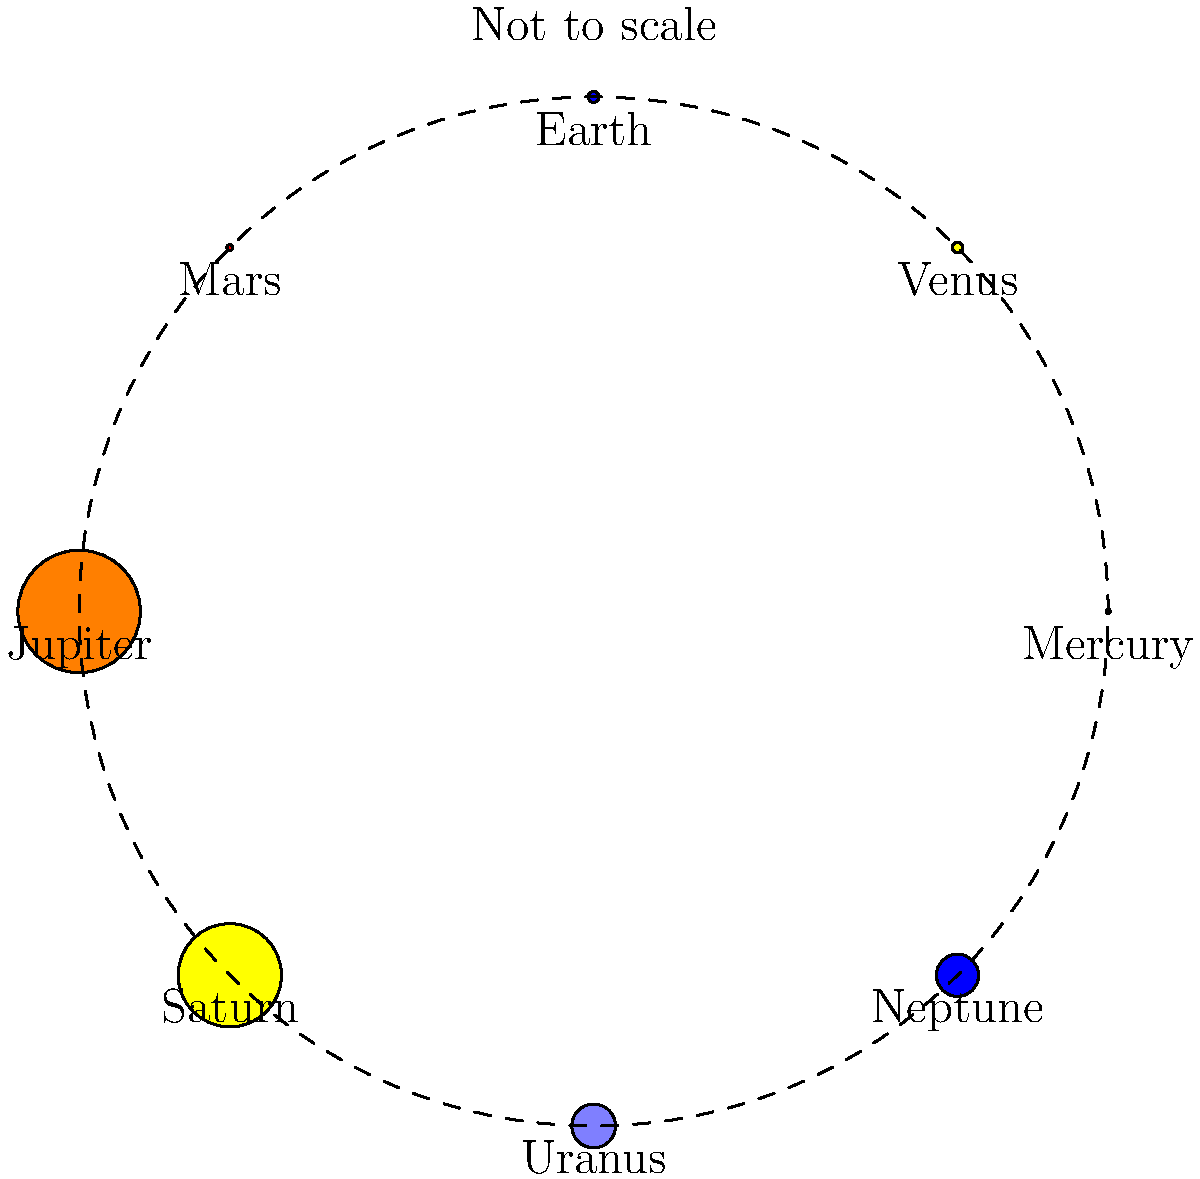In designing a Rocket Raccoon costume for a space-themed event, you want to incorporate accurate astronomical details. Which planet in our solar system would require the most fabric to create a proportionally sized costume accessory, and how does its size compare to Earth? To answer this question, we need to compare the relative sizes of the planets in our solar system:

1. First, let's list the diameters of the planets in kilometers:
   Mercury: 4,879 km
   Venus: 12,104 km
   Earth: 12,742 km
   Mars: 6,779 km
   Jupiter: 139,820 km
   Saturn: 116,460 km
   Uranus: 50,724 km
   Neptune: 49,244 km

2. From this list, we can see that Jupiter is the largest planet.

3. To compare Jupiter's size to Earth's, we can divide Jupiter's diameter by Earth's diameter:
   
   $\frac{139,820 \text{ km}}{12,742 \text{ km}} \approx 10.97$

4. This means Jupiter is about 11 times larger in diameter than Earth.

5. To calculate how much more surface area Jupiter has compared to Earth, we need to square this ratio:

   $11^2 = 121$

Therefore, Jupiter would require the most fabric to create a proportionally sized costume accessory, and it would need approximately 121 times more fabric than an Earth-sized accessory.
Answer: Jupiter; 121 times larger in surface area than Earth 